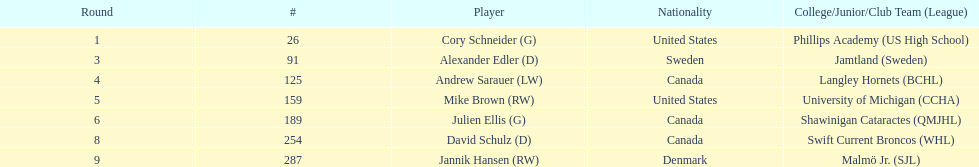How many goalies drafted? 2. 